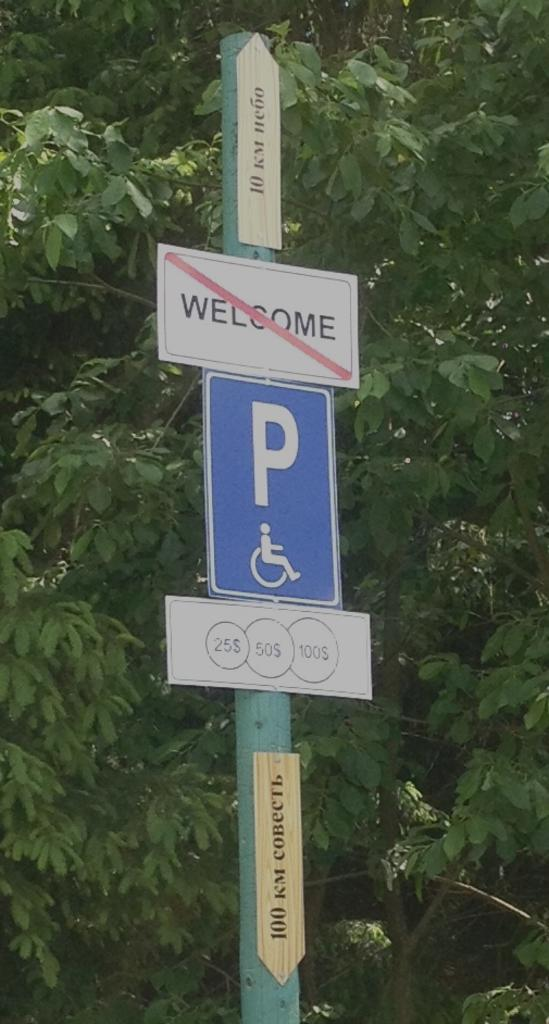What is the main structure in the image? There is a pole in the image. How many boards are attached to the pole? Three boards are fixed to the pole. What can be seen in the background of the image? There are trees in the background of the image. How many bananas are hanging from the pole in the image? There are no bananas present in the image. What type of trip can be seen in the image? There is no trip depicted in the image. 